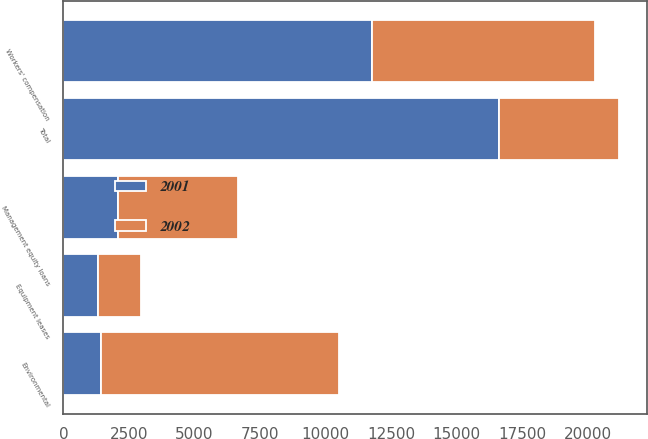Convert chart to OTSL. <chart><loc_0><loc_0><loc_500><loc_500><stacked_bar_chart><ecel><fcel>Workers' compensation<fcel>Environmental<fcel>Management equity loans<fcel>Equipment leases<fcel>Total<nl><fcel>2001<fcel>11775<fcel>1431<fcel>2065<fcel>1329<fcel>16600<nl><fcel>2002<fcel>8500<fcel>9079<fcel>4600<fcel>1643<fcel>4600<nl></chart> 